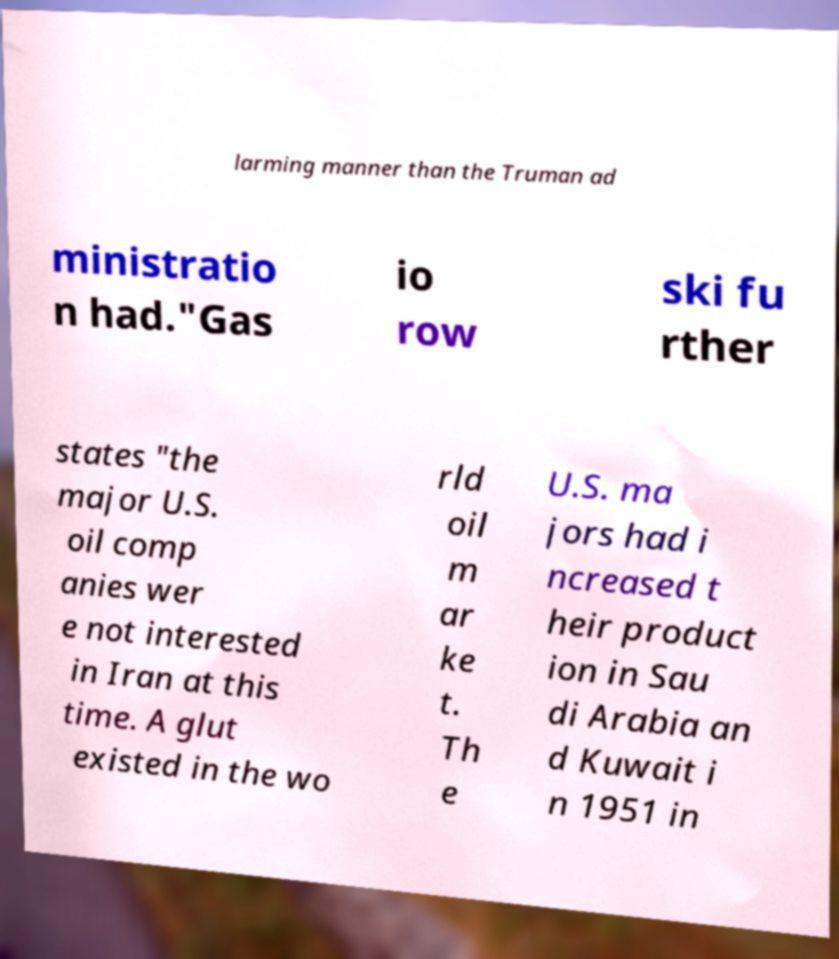Please identify and transcribe the text found in this image. larming manner than the Truman ad ministratio n had."Gas io row ski fu rther states "the major U.S. oil comp anies wer e not interested in Iran at this time. A glut existed in the wo rld oil m ar ke t. Th e U.S. ma jors had i ncreased t heir product ion in Sau di Arabia an d Kuwait i n 1951 in 